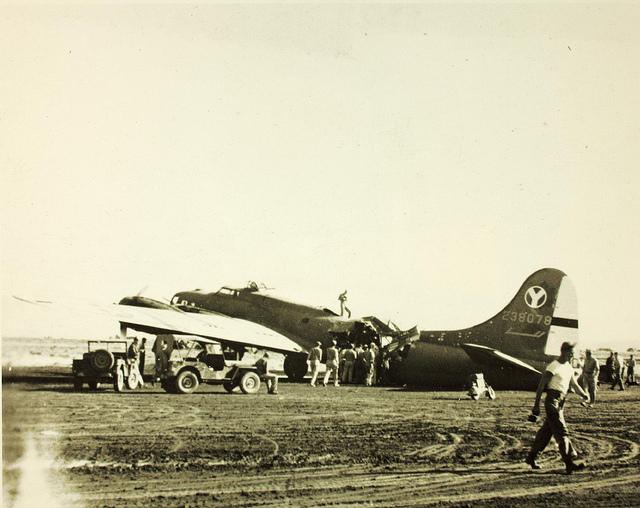Is that a new airplane?
Give a very brief answer. No. What is the main color tone of this photo?
Quick response, please. Black and white. Is this a recent photo?
Keep it brief. No. 